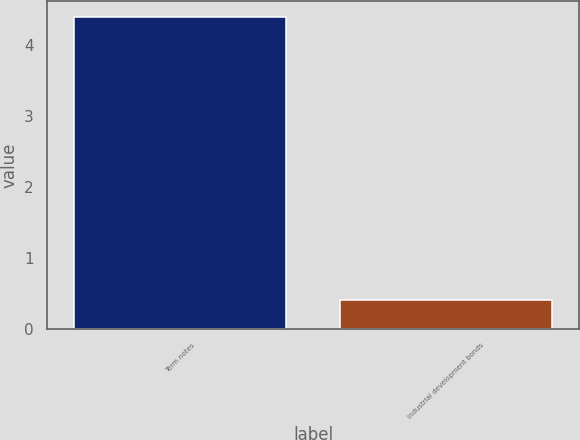Convert chart to OTSL. <chart><loc_0><loc_0><loc_500><loc_500><bar_chart><fcel>Term notes<fcel>Industrial development bonds<nl><fcel>4.4<fcel>0.4<nl></chart> 